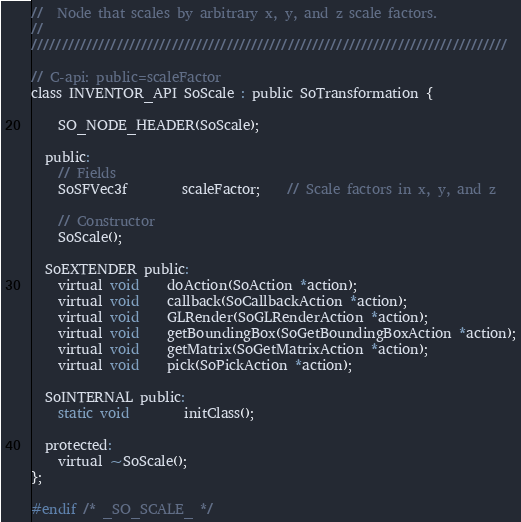<code> <loc_0><loc_0><loc_500><loc_500><_C_>//  Node that scales by arbitrary x, y, and z scale factors.
//
//////////////////////////////////////////////////////////////////////////////

// C-api: public=scaleFactor
class INVENTOR_API SoScale : public SoTransformation {

    SO_NODE_HEADER(SoScale);

  public:
    // Fields
    SoSFVec3f		scaleFactor;	// Scale factors in x, y, and z

    // Constructor
    SoScale();

  SoEXTENDER public:
    virtual void	doAction(SoAction *action);
    virtual void	callback(SoCallbackAction *action);
    virtual void	GLRender(SoGLRenderAction *action);
    virtual void	getBoundingBox(SoGetBoundingBoxAction *action);
    virtual void	getMatrix(SoGetMatrixAction *action);
    virtual void	pick(SoPickAction *action);

  SoINTERNAL public:
    static void		initClass();

  protected:
    virtual ~SoScale();
};

#endif /* _SO_SCALE_ */
</code> 